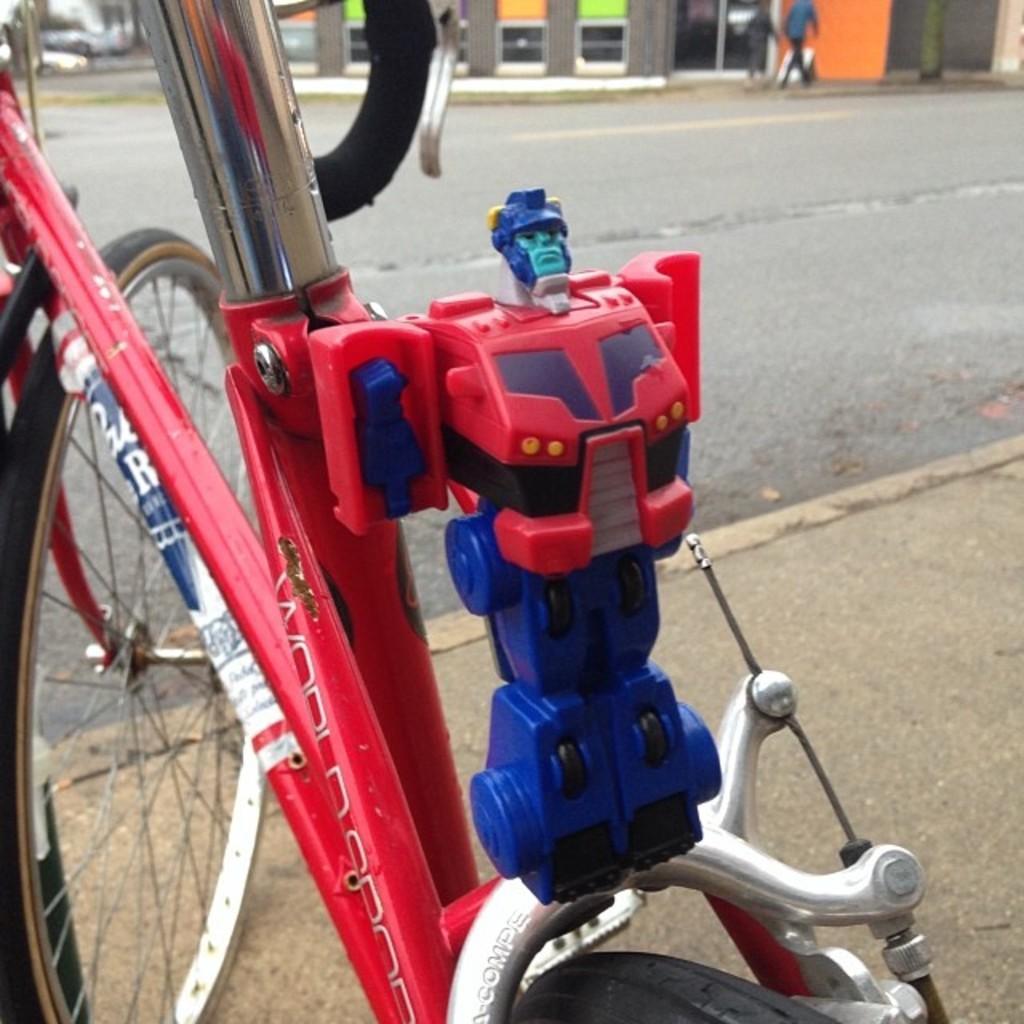How would you summarize this image in a sentence or two? In the image we can see there is a bicycle parked on the footpath and there is a human toy kept on the bicycle. Behind there is a road and there are people standing on the footpath. The image is little blurry at the back. 